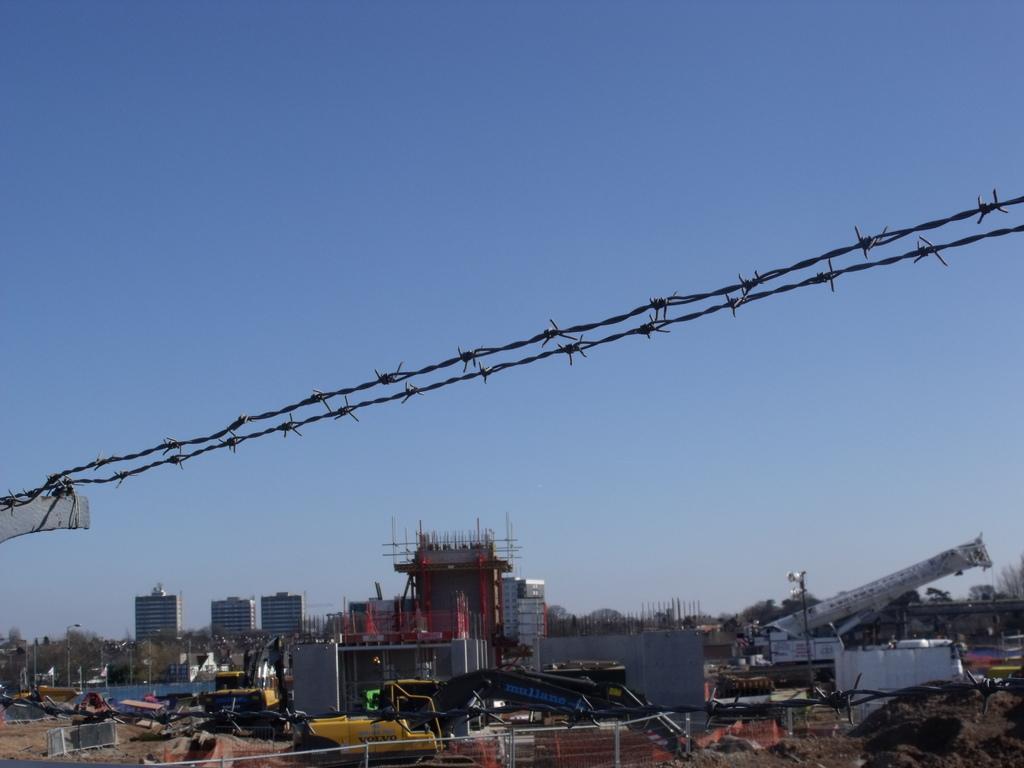Could you give a brief overview of what you see in this image? In the center of the image we can see the barbed wires. At the bottom of the image we can see the buildings, poles, flags, lights, trees, vehicles, mesh, sand, cranes. In the background of the image we can see the sky. 